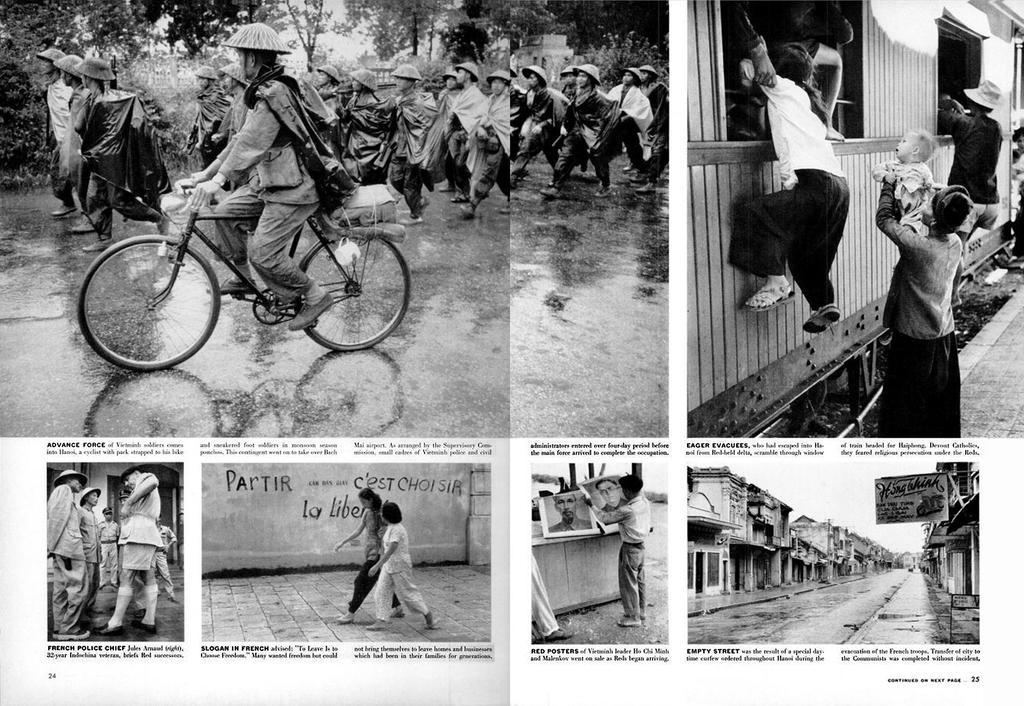Please provide a concise description of this image. This image consists of many people. It looks like the image is edited. To the top left, there are many people walking in the image. To the right, there is a woman climbing in the train from the window. At the bottom, there are roads and buildings in the images. 